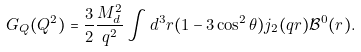<formula> <loc_0><loc_0><loc_500><loc_500>G _ { Q } ( Q ^ { 2 } ) = \frac { 3 } { 2 } \frac { M ^ { 2 } _ { d } } { q ^ { 2 } } \int d ^ { 3 } r ( 1 - 3 \cos ^ { 2 } \theta ) j _ { 2 } ( q r ) \mathcal { B } ^ { 0 } ( r ) .</formula> 